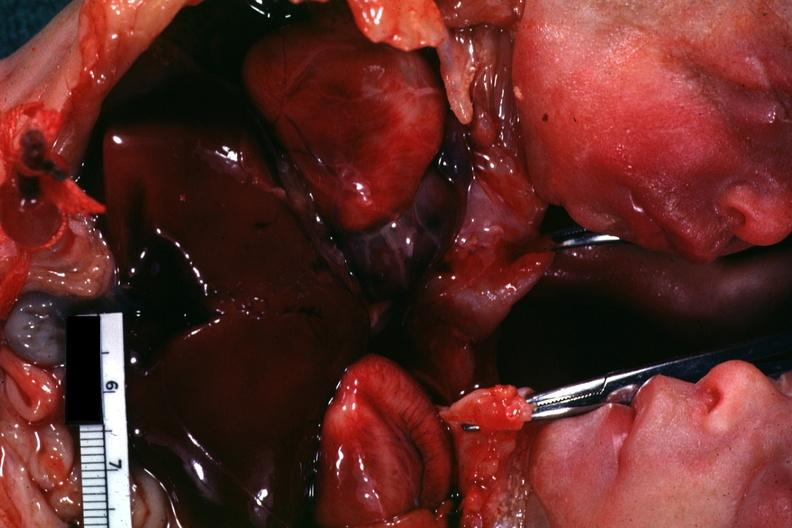how many hearts does chest and abdomen slide show opened chest with?
Answer the question using a single word or phrase. Two 